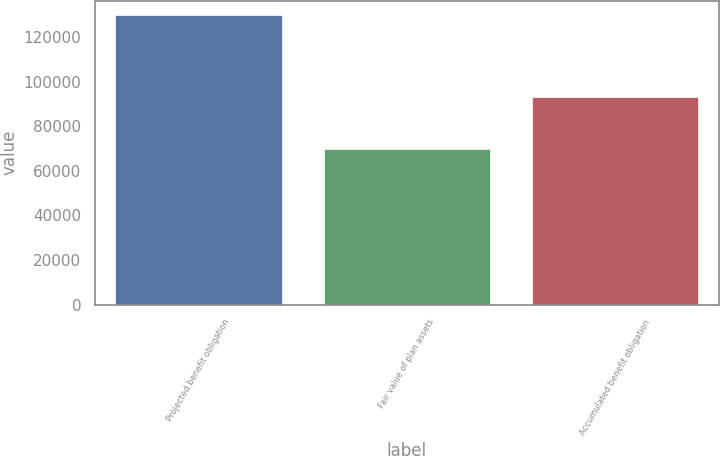Convert chart. <chart><loc_0><loc_0><loc_500><loc_500><bar_chart><fcel>Projected benefit obligation<fcel>Fair value of plan assets<fcel>Accumulated benefit obligation<nl><fcel>129711<fcel>69823<fcel>93164<nl></chart> 